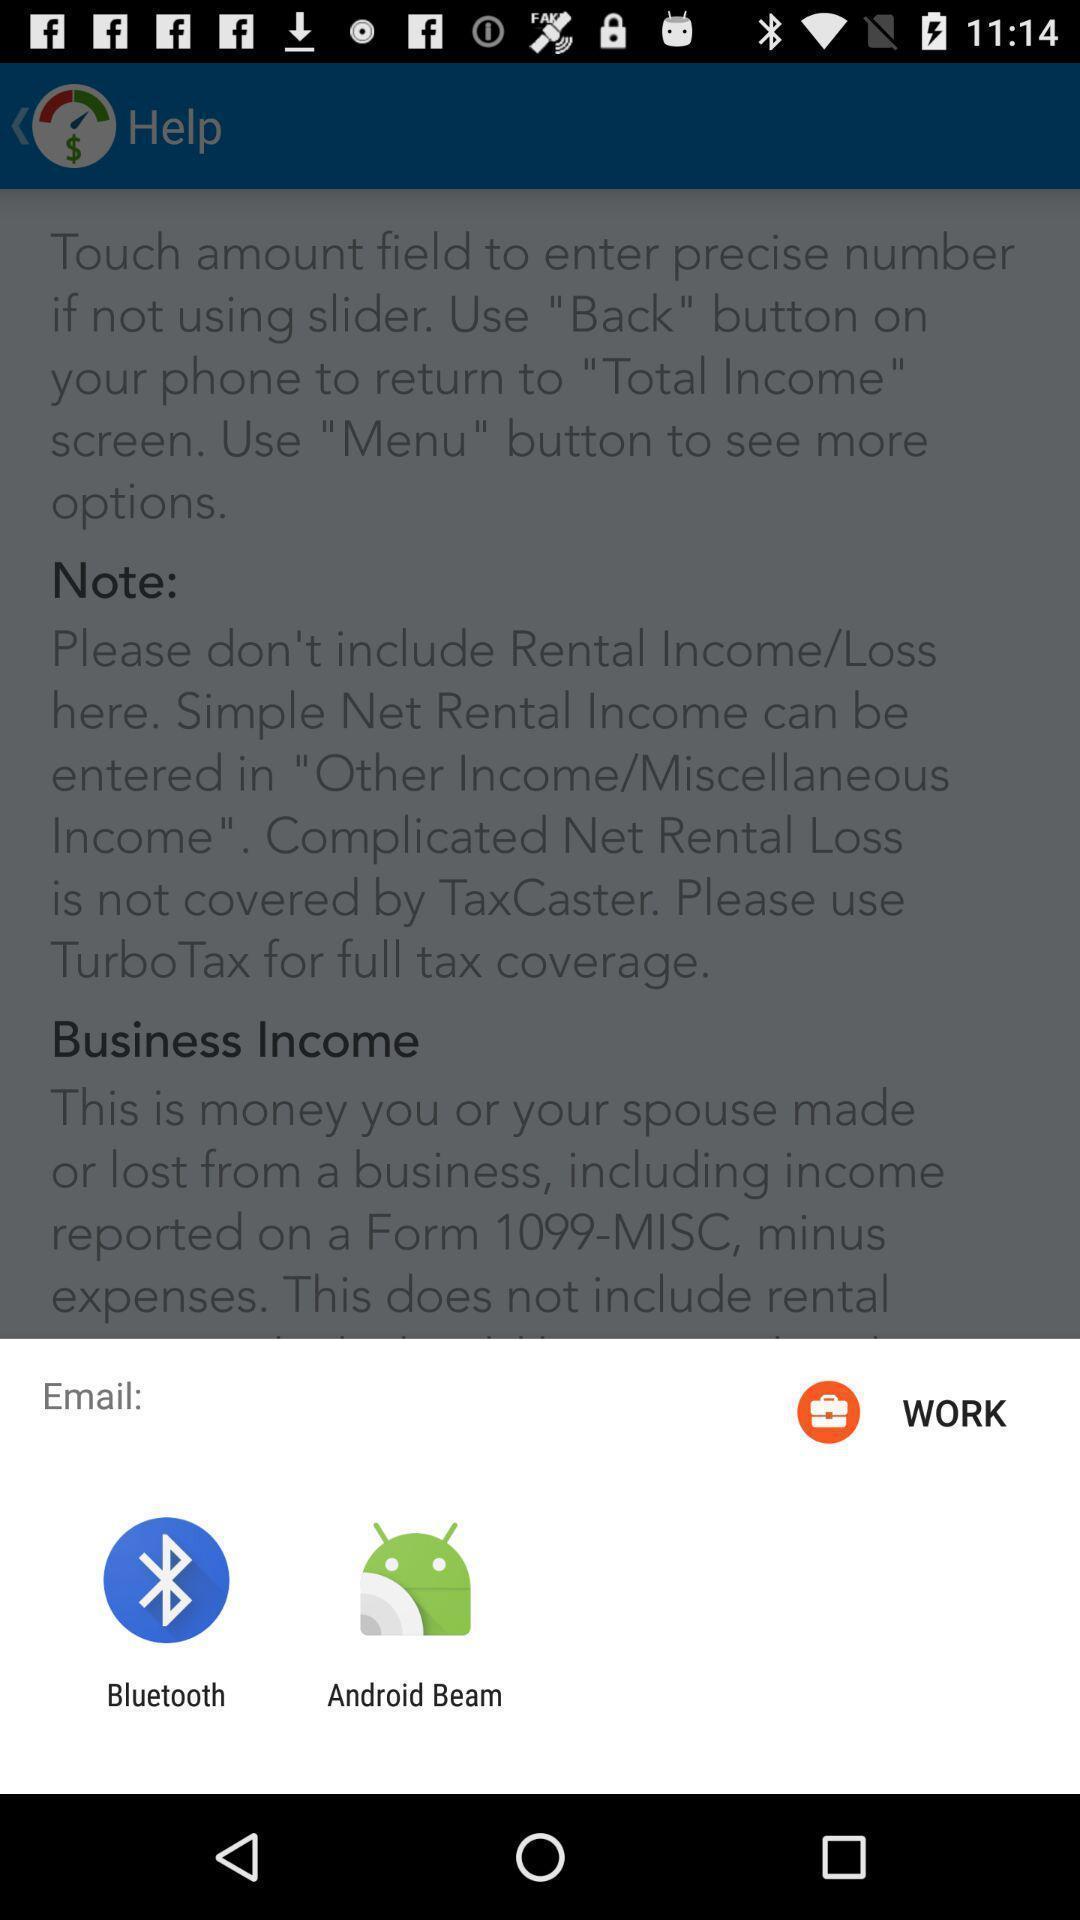Give me a narrative description of this picture. Pop-up show to email with multiple applications. 